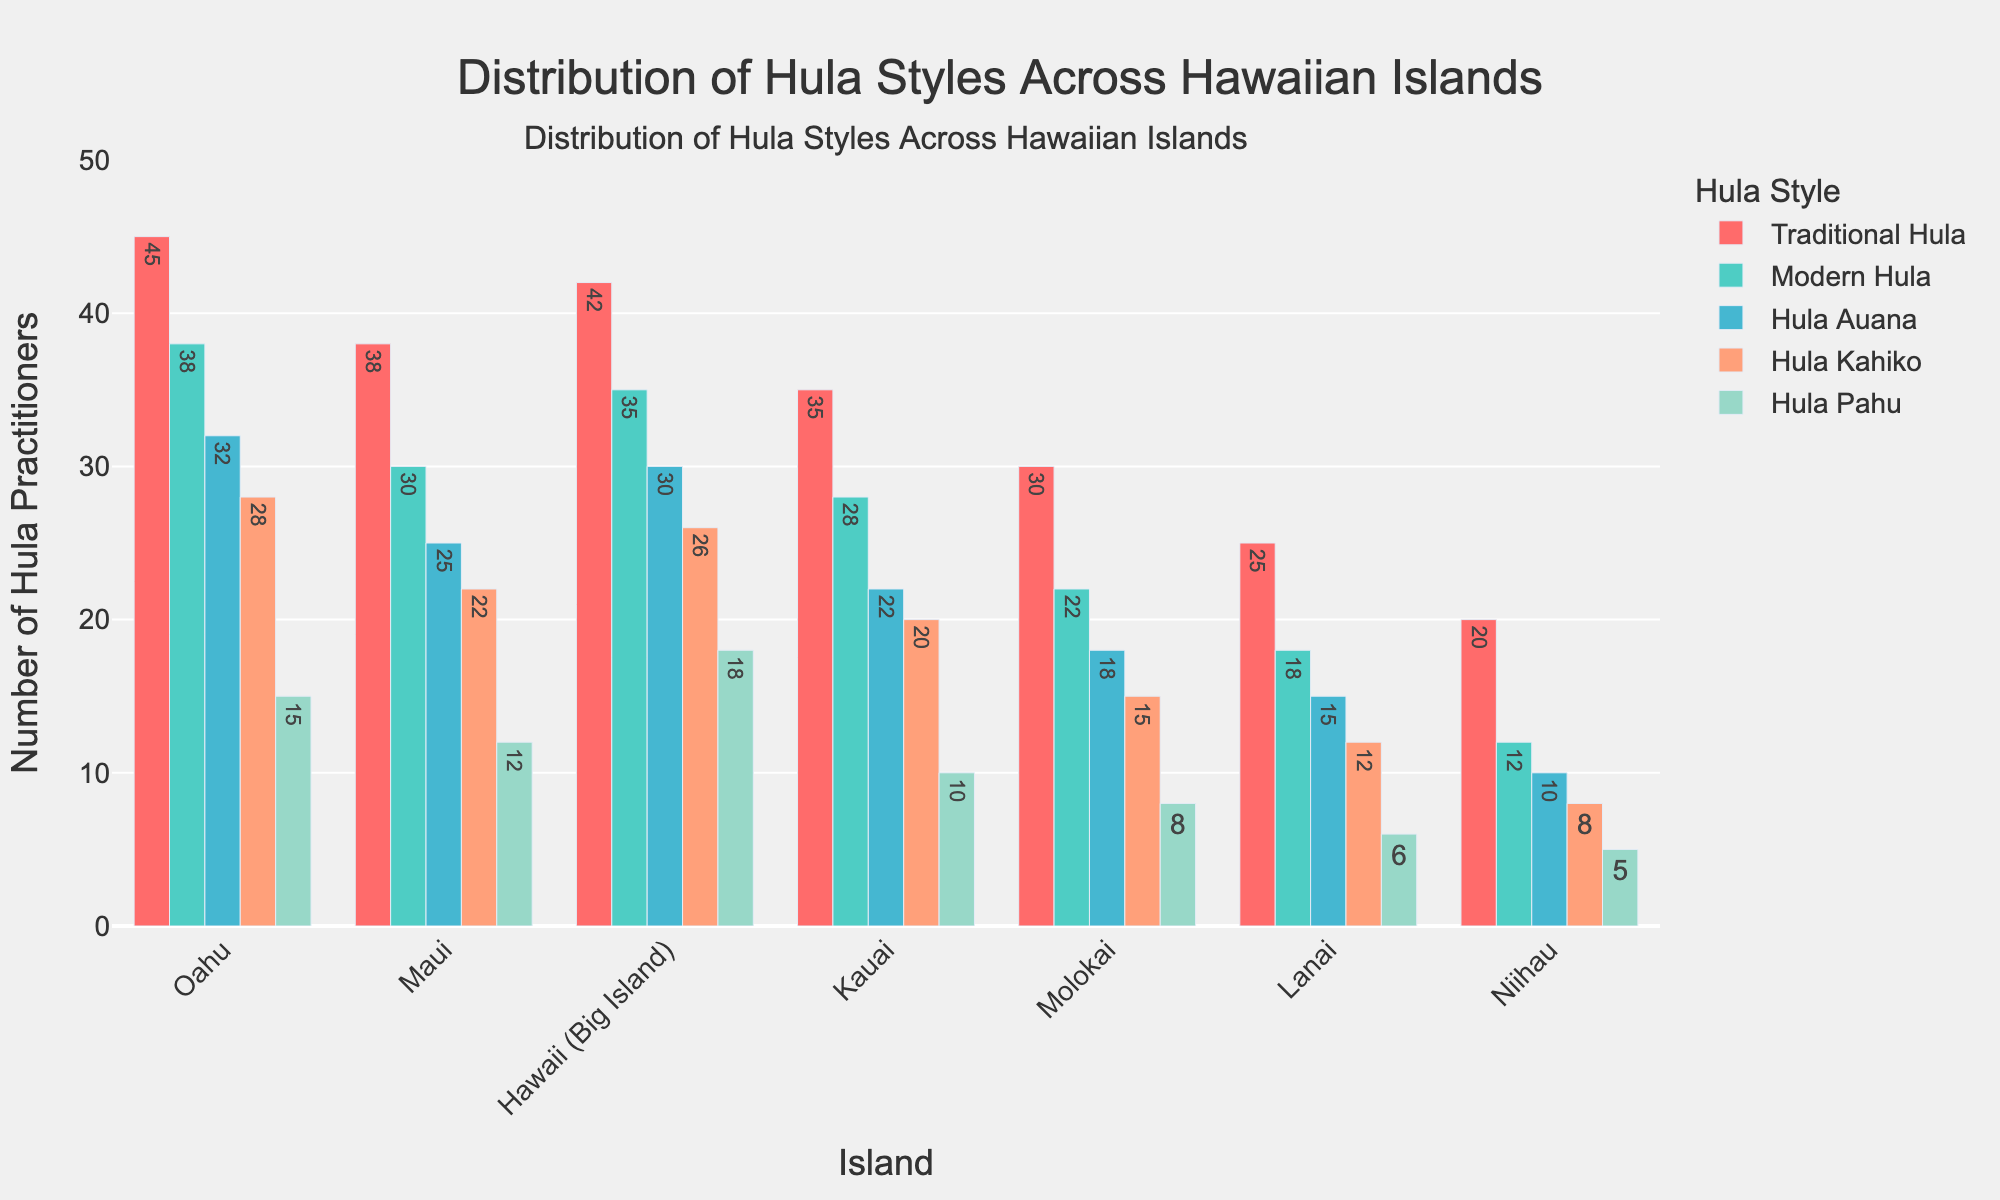Which island has the highest number of practitioners for Traditional Hula? By comparing the heights of the bars representing Traditional Hula across all islands, Oahu has the tallest bar.
Answer: Oahu Which style of hula is practiced by the least number of people on Lanai? By checking the heights of the bars for different styles of hula on Lanai, the bar for Hula Pahu is the shortest.
Answer: Hula Pahu How many more practitioners of Modern Hula are there on Hawaii (Big Island) compared to Niihau? The number of Modern Hula practitioners on Hawaii (Big Island) is 35 and on Niihau is 12. The difference is 35 - 12.
Answer: 23 Which island has the most balanced distribution of practitioners across all hula styles? By visually inspecting the bar heights for each style on every island, Molokai has relatively similar heights across all styles.
Answer: Molokai What is the total number of Hula Auana practitioners on all islands combined? Summing up the number of Hula Auana practitioners from all the islands: 32 (Oahu) + 25 (Maui) + 30 (Hawaii) + 22 (Kauai) + 18 (Molokai) + 15 (Lanai) + 10 (Niihau) = 152.
Answer: 152 Which island has more practitioners of Hula Kahiko than Modern Hula? Inspecting the bar heights for Hula Kahiko and Modern Hula, Oahu has a higher bar for Hula Kahiko (28) than for Modern Hula (26).
Answer: Oahu What is the average number of practitioners of Hula Pahu across all the islands? Adding the number of Hula Pahu practitioners on each island and dividing by the number of islands: (15 + 12 + 18 + 10 + 8 + 6 + 5) / 7 = 10.57 (approximately).
Answer: 10.57 Which hula style has the widest variation in the number of practitioners across the islands? By comparing the range (maximum minus minimum) of practitioners for each style, Traditional Hula ranges from a maximum of 45 on Oahu to a minimum of 20 on Niihau, which is a difference of 25, making it the widest variation.
Answer: Traditional Hula 